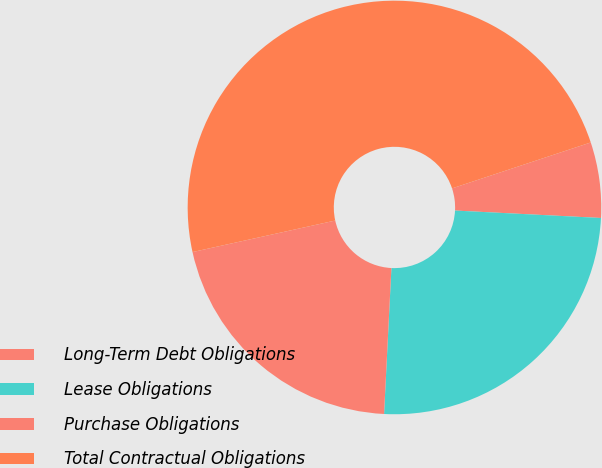Convert chart. <chart><loc_0><loc_0><loc_500><loc_500><pie_chart><fcel>Long-Term Debt Obligations<fcel>Lease Obligations<fcel>Purchase Obligations<fcel>Total Contractual Obligations<nl><fcel>5.9%<fcel>24.99%<fcel>20.74%<fcel>48.37%<nl></chart> 